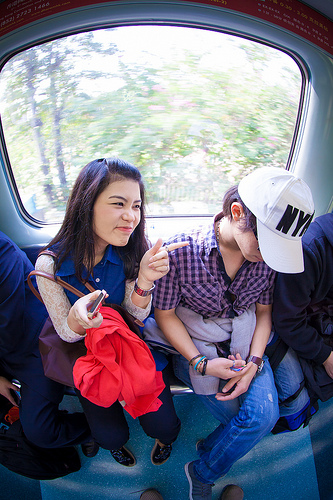<image>
Is there a girl on the girl? No. The girl is not positioned on the girl. They may be near each other, but the girl is not supported by or resting on top of the girl. 